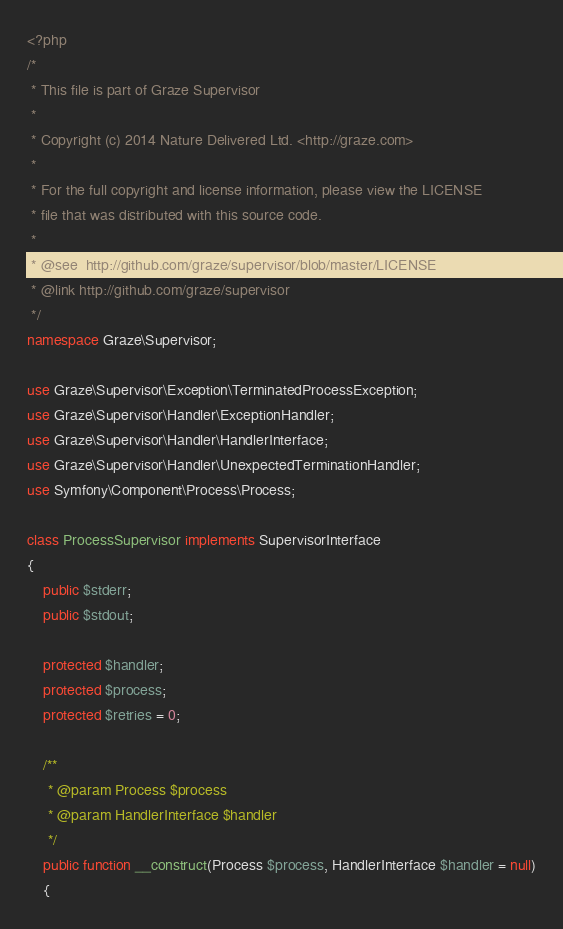<code> <loc_0><loc_0><loc_500><loc_500><_PHP_><?php
/*
 * This file is part of Graze Supervisor
 *
 * Copyright (c) 2014 Nature Delivered Ltd. <http://graze.com>
 *
 * For the full copyright and license information, please view the LICENSE
 * file that was distributed with this source code.
 *
 * @see  http://github.com/graze/supervisor/blob/master/LICENSE
 * @link http://github.com/graze/supervisor
 */
namespace Graze\Supervisor;

use Graze\Supervisor\Exception\TerminatedProcessException;
use Graze\Supervisor\Handler\ExceptionHandler;
use Graze\Supervisor\Handler\HandlerInterface;
use Graze\Supervisor\Handler\UnexpectedTerminationHandler;
use Symfony\Component\Process\Process;

class ProcessSupervisor implements SupervisorInterface
{
    public $stderr;
    public $stdout;

    protected $handler;
    protected $process;
    protected $retries = 0;

    /**
     * @param Process $process
     * @param HandlerInterface $handler
     */
    public function __construct(Process $process, HandlerInterface $handler = null)
    {</code> 